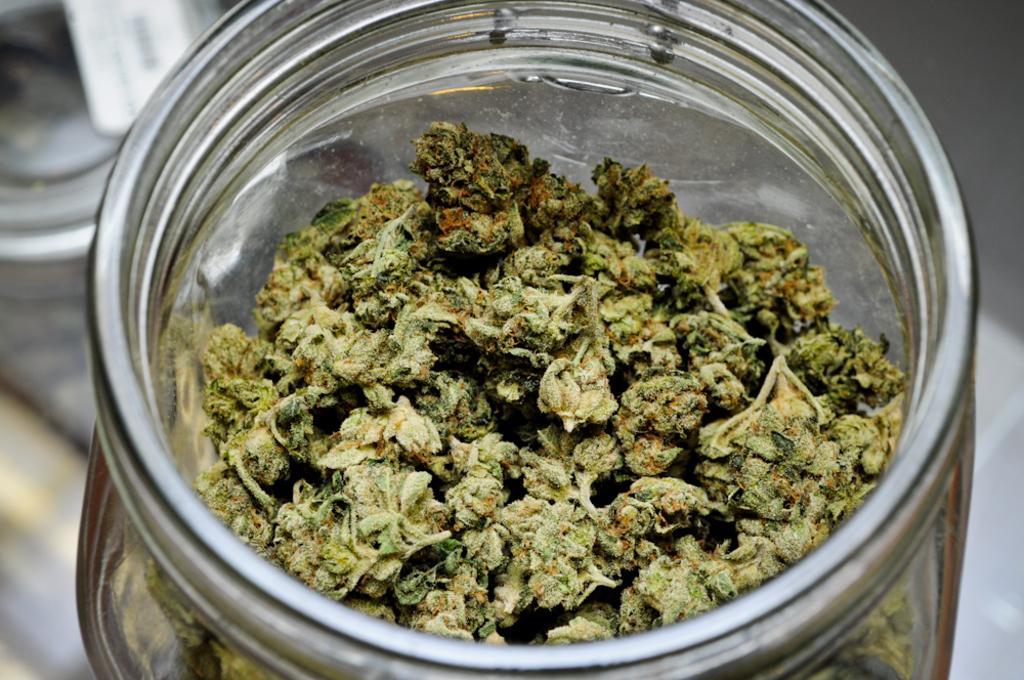How would you summarize this image in a sentence or two? In this image we can see some food item in the jar. 